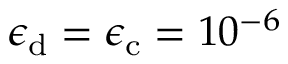Convert formula to latex. <formula><loc_0><loc_0><loc_500><loc_500>\epsilon _ { d } = \epsilon _ { c } = 1 0 ^ { - 6 }</formula> 